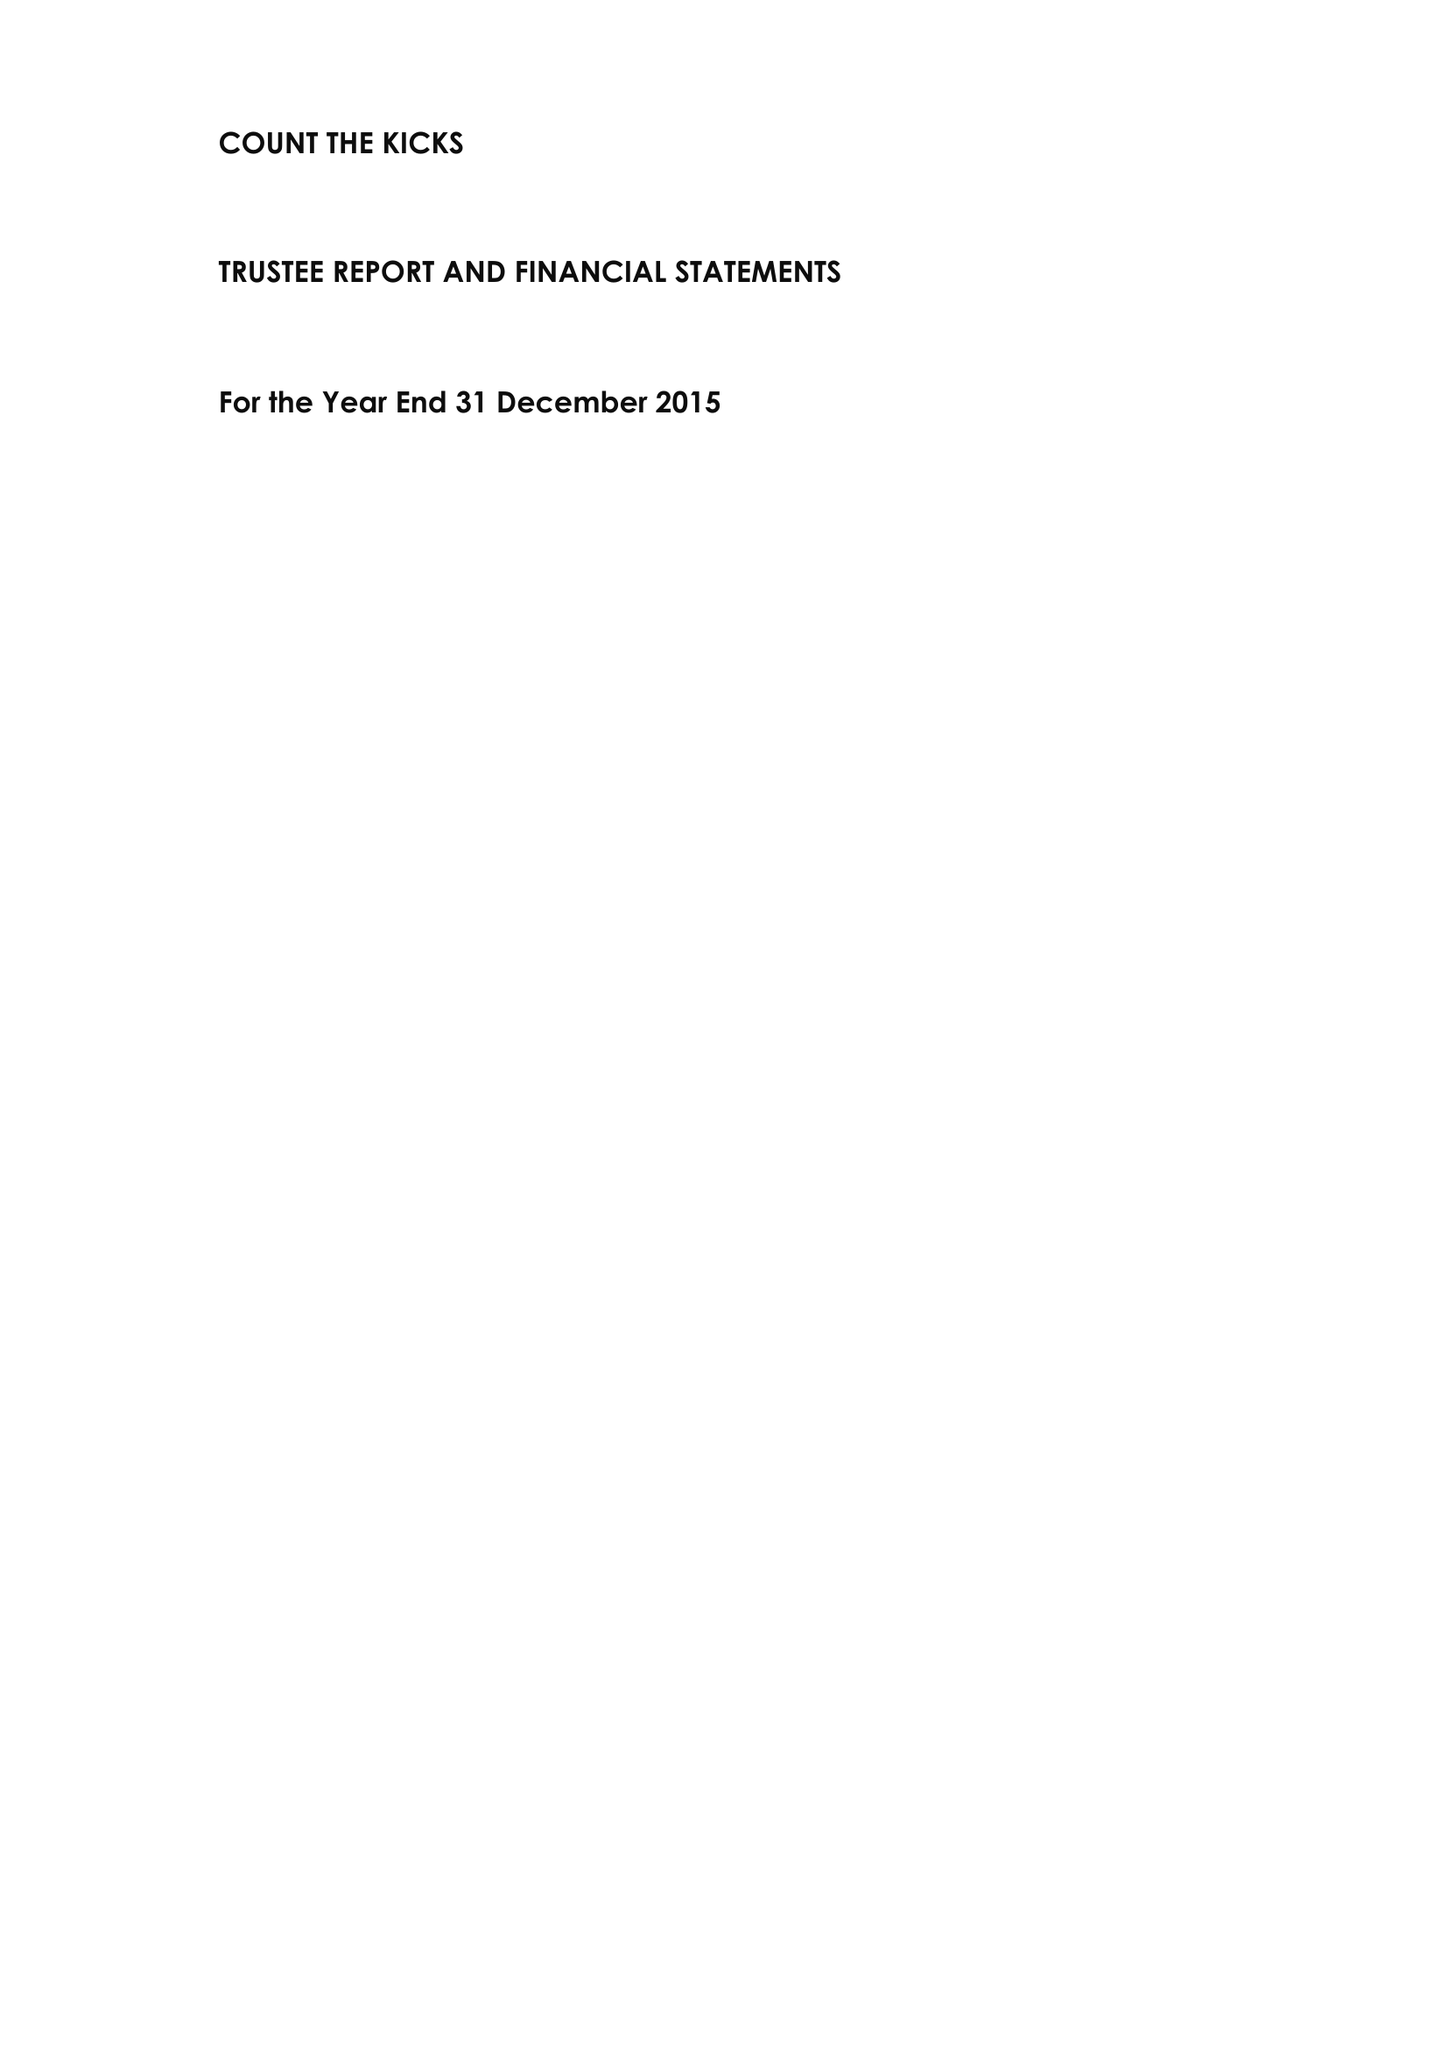What is the value for the address__postcode?
Answer the question using a single word or phrase. GU23 6BN 